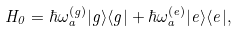Convert formula to latex. <formula><loc_0><loc_0><loc_500><loc_500>H _ { 0 } = \hbar { \omega } _ { a } ^ { ( g ) } | g \rangle \langle g | + \hbar { \omega } _ { a } ^ { ( e ) } | e \rangle \langle e | ,</formula> 